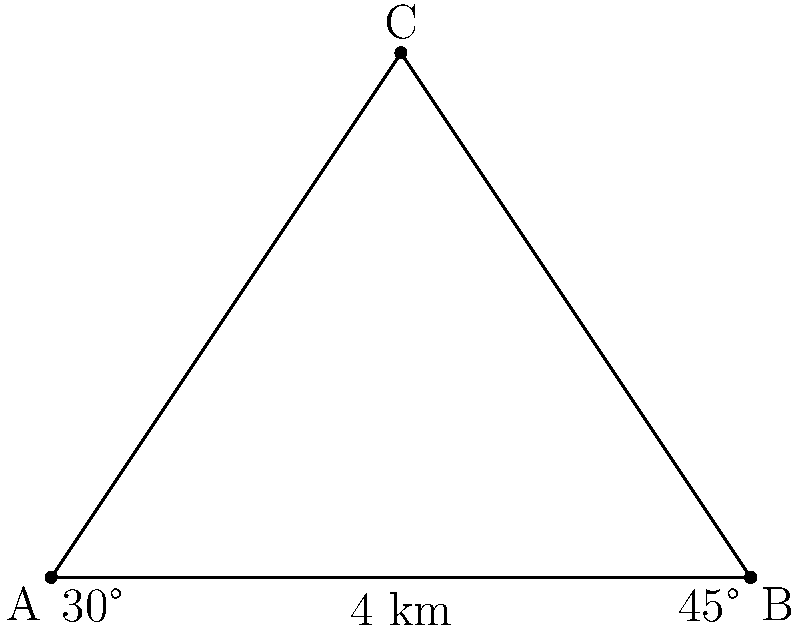During a military exercise, you need to determine the location of an unknown point C using triangulation. You have two known landmarks: point A (your current position) and point B (a communications tower). The distance between A and B is 8 km. The angle between AC and AB is 30°, and the angle between BC and BA is 45°. Calculate the distance from your position (A) to the unknown point C. Let's solve this step-by-step using the law of sines:

1) In triangle ABC, we know two angles and one side:
   - Angle A = 30°
   - Angle B = 45°
   - Side AB = 8 km

2) We can find the third angle C:
   $C = 180° - (30° + 45°) = 105°$

3) Now we can use the law of sines:
   $\frac{a}{\sin A} = \frac{b}{\sin B} = \frac{c}{\sin C}$

   Where $a$, $b$, and $c$ are the sides opposite to angles A, B, and C respectively.

4) We want to find side $a$ (AC). We can use:
   $\frac{a}{\sin 30°} = \frac{8}{\sin 45°}$

5) Rearranging:
   $a = \frac{8 \sin 30°}{\sin 45°}$

6) Calculating:
   $a = \frac{8 \cdot 0.5}{\frac{\sqrt{2}}{2}} = \frac{4}{\frac{\sqrt{2}}{2}} = 4\sqrt{2} \approx 5.66$ km

Therefore, the distance from your position (A) to the unknown point C is approximately 5.66 km.
Answer: $4\sqrt{2}$ km or approximately 5.66 km 